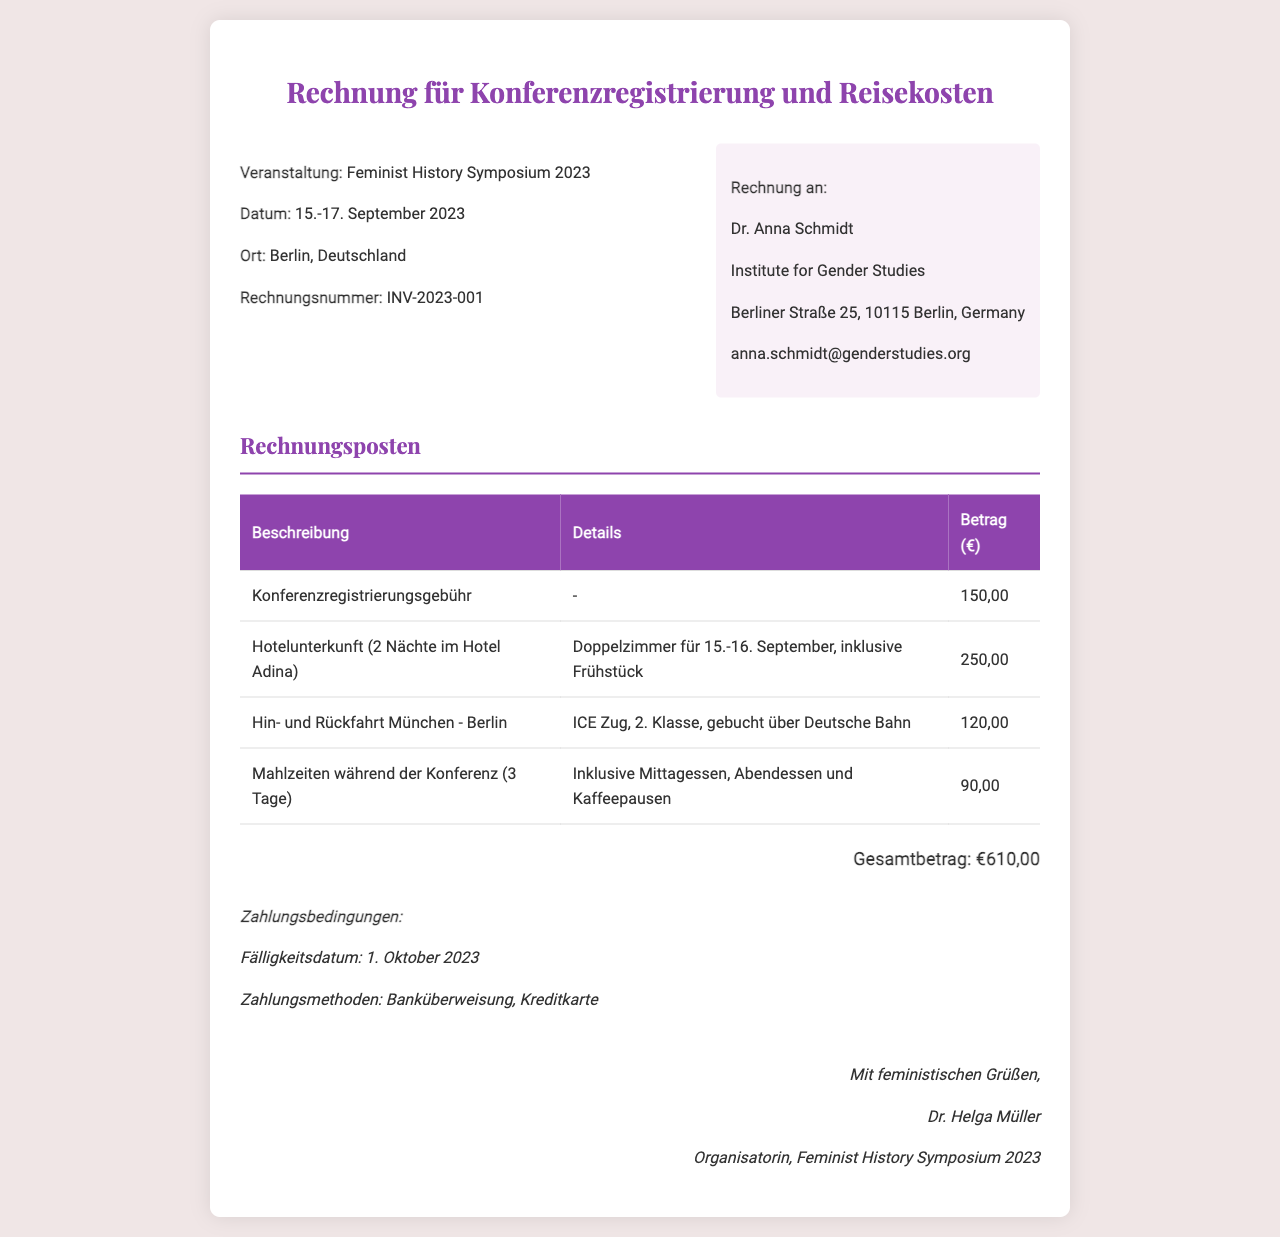What is the event title? The event title is clearly stated at the top of the invoice as the "Feminist History Symposium 2023."
Answer: Feminist History Symposium 2023 What is the invoice number? The invoice number is provided in the header section of the document as "INV-2023-001."
Answer: INV-2023-001 What is the total amount due? The total amount is summarized at the bottom of the invoice as "€610,00."
Answer: €610,00 What are the dates of the event? The dates of the event are specified in the document as "15.-17. September 2023."
Answer: 15.-17. September 2023 Which hotel was used for accommodation? The accommodation details specify the hotel as "Hotel Adina."
Answer: Hotel Adina How many nights is the hotel accommodation charged for? The document states that the accommodation is for "2 Nächte," or two nights.
Answer: 2 Nächte What is the amount for meals during the conference? The invoice lists the cost for meals as "€90,00."
Answer: €90,00 What is the payment due date? The payment due date is mentioned as "1. Oktober 2023."
Answer: 1. Oktober 2023 Who is the organizer of the event? The organizer's name is given at the bottom of the invoice as "Dr. Helga Müller."
Answer: Dr. Helga Müller 